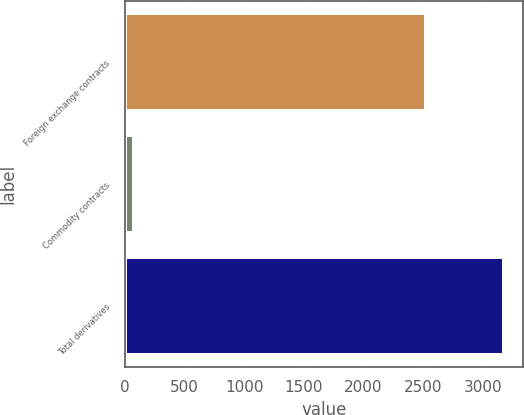Convert chart. <chart><loc_0><loc_0><loc_500><loc_500><bar_chart><fcel>Foreign exchange contracts<fcel>Commodity contracts<fcel>Total derivatives<nl><fcel>2524<fcel>72<fcel>3177<nl></chart> 